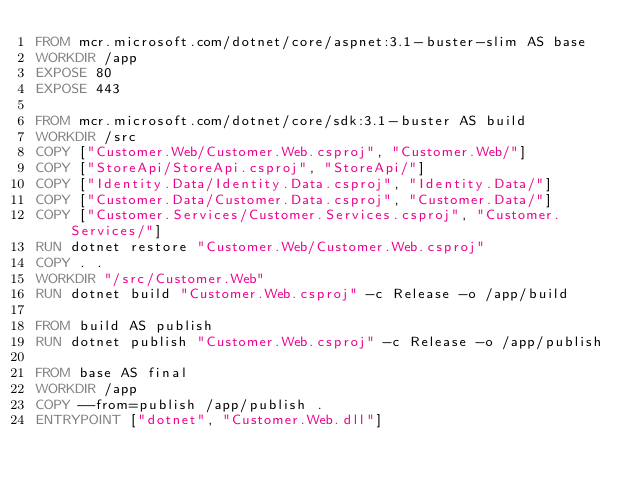<code> <loc_0><loc_0><loc_500><loc_500><_Dockerfile_>FROM mcr.microsoft.com/dotnet/core/aspnet:3.1-buster-slim AS base
WORKDIR /app
EXPOSE 80
EXPOSE 443

FROM mcr.microsoft.com/dotnet/core/sdk:3.1-buster AS build
WORKDIR /src
COPY ["Customer.Web/Customer.Web.csproj", "Customer.Web/"]
COPY ["StoreApi/StoreApi.csproj", "StoreApi/"]
COPY ["Identity.Data/Identity.Data.csproj", "Identity.Data/"]
COPY ["Customer.Data/Customer.Data.csproj", "Customer.Data/"]
COPY ["Customer.Services/Customer.Services.csproj", "Customer.Services/"]
RUN dotnet restore "Customer.Web/Customer.Web.csproj"
COPY . .
WORKDIR "/src/Customer.Web"
RUN dotnet build "Customer.Web.csproj" -c Release -o /app/build

FROM build AS publish
RUN dotnet publish "Customer.Web.csproj" -c Release -o /app/publish

FROM base AS final
WORKDIR /app
COPY --from=publish /app/publish .
ENTRYPOINT ["dotnet", "Customer.Web.dll"]</code> 